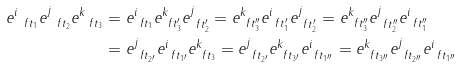<formula> <loc_0><loc_0><loc_500><loc_500>e ^ { i } _ { \ f t _ { 1 } } e ^ { j } _ { \ f t _ { 2 } } e ^ { k } _ { \ f t _ { 3 } } & = e ^ { i } _ { \ f t _ { 1 } } e ^ { k } _ { \ f t _ { 3 } ^ { \prime } } e ^ { j } _ { \ f t _ { 2 } ^ { \prime } } = e ^ { k } _ { \ f t _ { 3 } ^ { \prime \prime } } e ^ { i } _ { \ f t _ { 1 } ^ { \prime } } e ^ { j } _ { \ f t _ { 2 } ^ { \prime } } = e ^ { k } _ { \ f t _ { 3 } ^ { \prime \prime } } e ^ { j } _ { \ f t _ { 2 } ^ { \prime \prime } } e ^ { i } _ { \ f t _ { 1 } ^ { \prime \prime } } \\ & = e ^ { j } _ { \ f t _ { 2 ^ { \prime } } } e ^ { i } _ { \ f t _ { 1 ^ { \prime } } } e ^ { k } _ { \ f t _ { 3 } } = e ^ { j } _ { \ f t _ { 2 ^ { \prime } } } e ^ { k } _ { \ f t _ { 3 ^ { \prime } } } e ^ { i } _ { \ f t _ { 1 ^ { \prime \prime } } } = e ^ { k } _ { \ f t _ { 3 ^ { \prime \prime } } } e ^ { j } _ { \ f t _ { 2 ^ { \prime \prime } } } e ^ { i } _ { \ f t _ { 1 ^ { \prime \prime } } }</formula> 